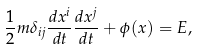<formula> <loc_0><loc_0><loc_500><loc_500>\frac { 1 } { 2 } m \delta _ { i j } \frac { d x ^ { i } } { d t } \frac { d x ^ { j } } { d t } + \phi ( x ) = E ,</formula> 